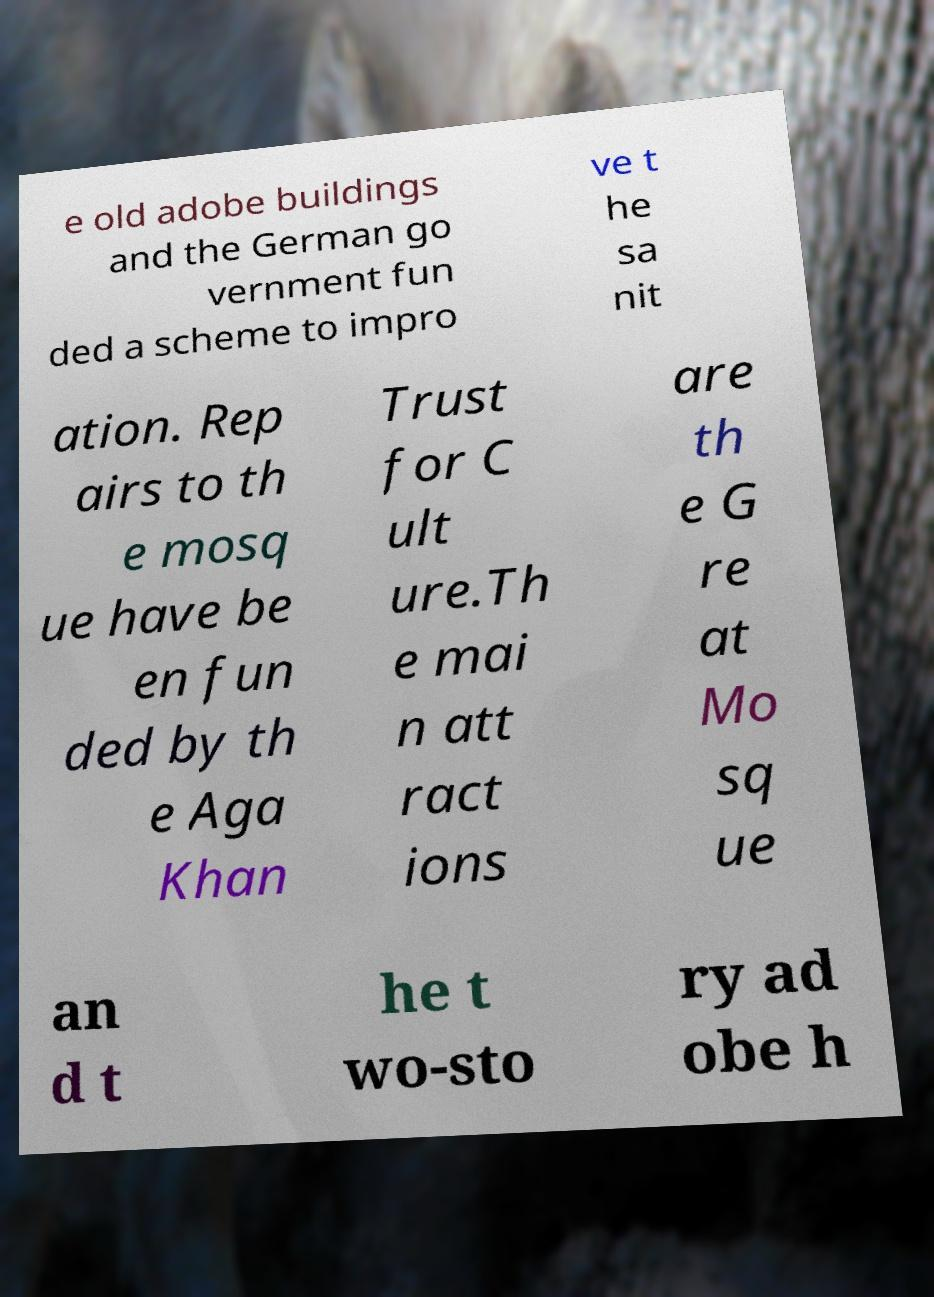Could you assist in decoding the text presented in this image and type it out clearly? e old adobe buildings and the German go vernment fun ded a scheme to impro ve t he sa nit ation. Rep airs to th e mosq ue have be en fun ded by th e Aga Khan Trust for C ult ure.Th e mai n att ract ions are th e G re at Mo sq ue an d t he t wo-sto ry ad obe h 